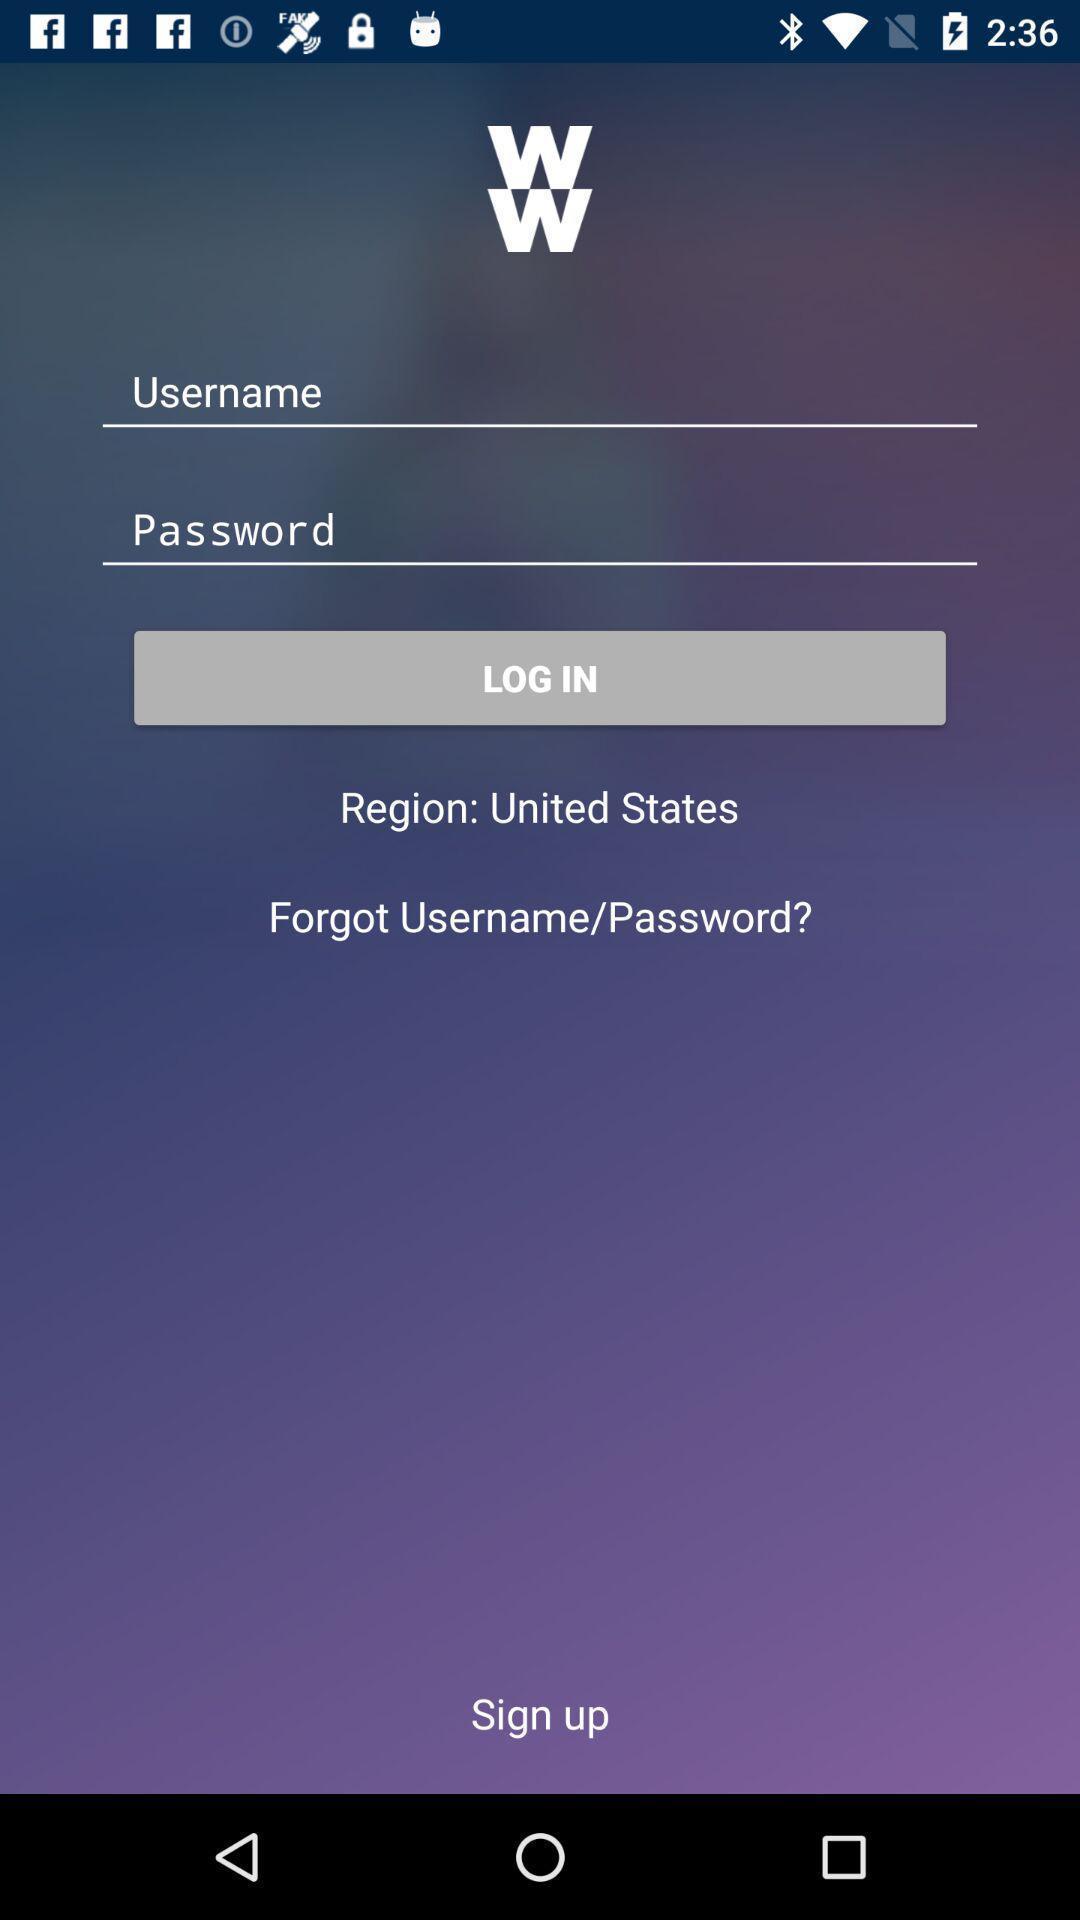Tell me about the visual elements in this screen capture. Screen displaying contents in login page. 